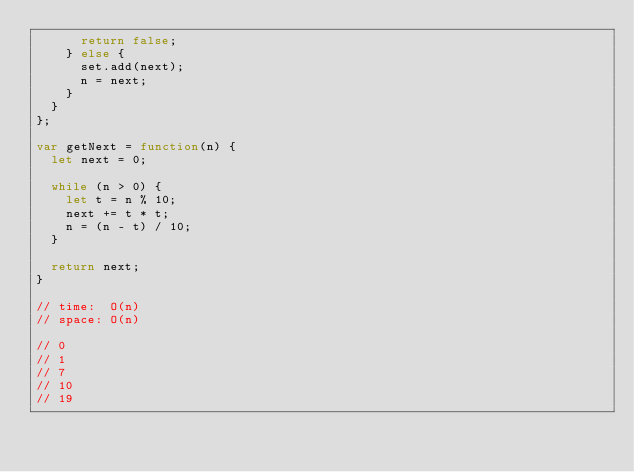<code> <loc_0><loc_0><loc_500><loc_500><_JavaScript_>      return false;
    } else {
      set.add(next);
      n = next;
    }
  }
};

var getNext = function(n) {
  let next = 0;

  while (n > 0) {
    let t = n % 10;
    next += t * t;
    n = (n - t) / 10;
  }

  return next;
}

// time:  O(n)
// space: O(n)

// 0
// 1
// 7
// 10
// 19
</code> 